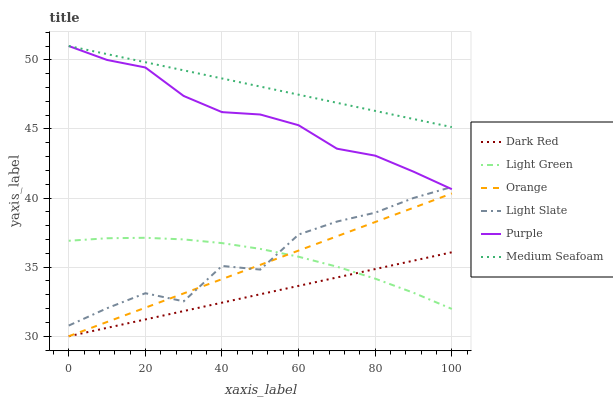Does Purple have the minimum area under the curve?
Answer yes or no. No. Does Purple have the maximum area under the curve?
Answer yes or no. No. Is Purple the smoothest?
Answer yes or no. No. Is Purple the roughest?
Answer yes or no. No. Does Purple have the lowest value?
Answer yes or no. No. Does Dark Red have the highest value?
Answer yes or no. No. Is Orange less than Medium Seafoam?
Answer yes or no. Yes. Is Medium Seafoam greater than Light Green?
Answer yes or no. Yes. Does Orange intersect Medium Seafoam?
Answer yes or no. No. 